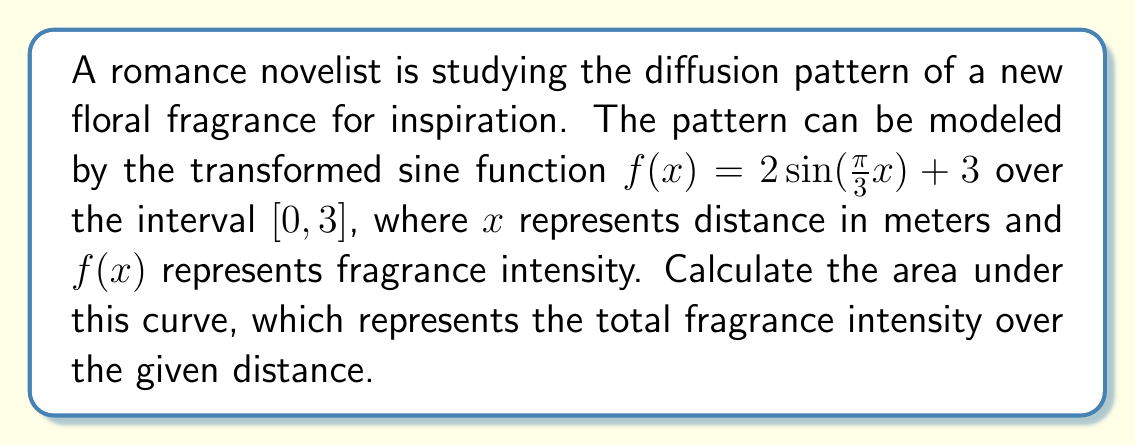Provide a solution to this math problem. To find the area under the curve, we need to integrate the function over the given interval:

1) Set up the integral:
   $$A = \int_0^3 (2\sin(\frac{\pi}{3}x) + 3) dx$$

2) Split the integral:
   $$A = \int_0^3 2\sin(\frac{\pi}{3}x) dx + \int_0^3 3 dx$$

3) For the first integral, use substitution:
   Let $u = \frac{\pi}{3}x$, then $du = \frac{\pi}{3}dx$, or $dx = \frac{3}{\pi}du$
   When $x = 0$, $u = 0$; when $x = 3$, $u = \pi$

   $$\int_0^3 2\sin(\frac{\pi}{3}x) dx = \frac{6}{\pi}\int_0^\pi \sin(u) du$$

4) Solve the first integral:
   $$\frac{6}{\pi}[-\cos(u)]_0^\pi = \frac{6}{\pi}[-\cos(\pi) - (-\cos(0))] = \frac{6}{\pi}[1 + 1] = \frac{12}{\pi}$$

5) Solve the second integral:
   $$\int_0^3 3 dx = 3x|_0^3 = 9$$

6) Sum the results:
   $$A = \frac{12}{\pi} + 9$$
Answer: $\frac{12}{\pi} + 9$ square meters 